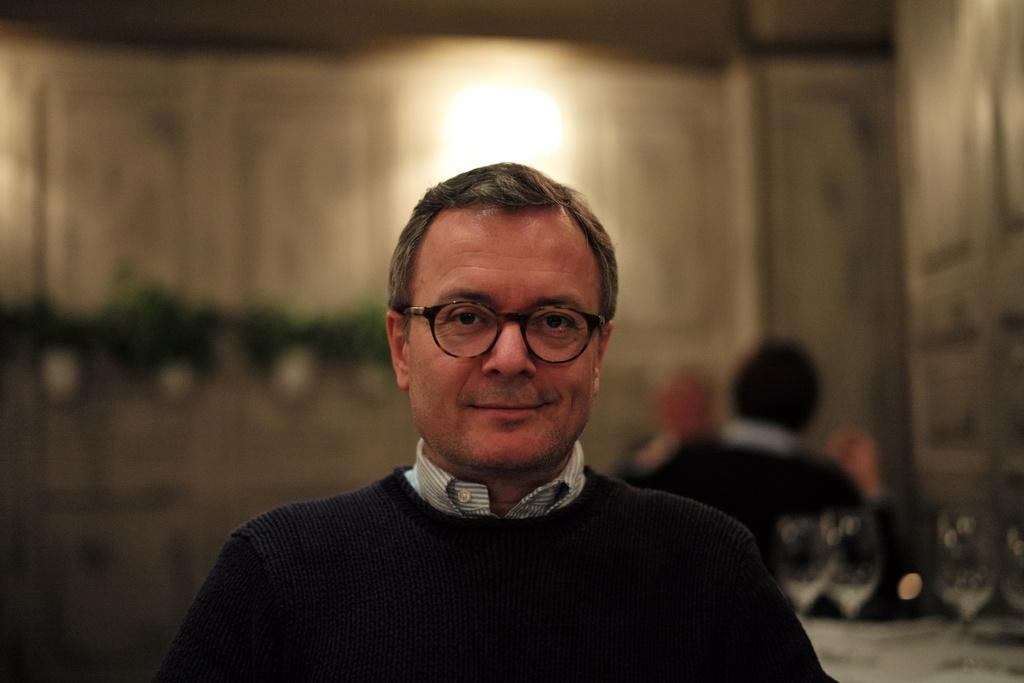What is the main subject of the image? There is a person in the image. Can you describe the background of the image? The background of the image is blurred. What is the person in the image wearing? The person is wearing clothes. Are there any accessories visible on the person? Yes, the person is wearing spectacles. What type of trouble is the person experiencing on the sidewalk in the image? There is no sidewalk or trouble mentioned in the image; it only features a person on a blurred background. 